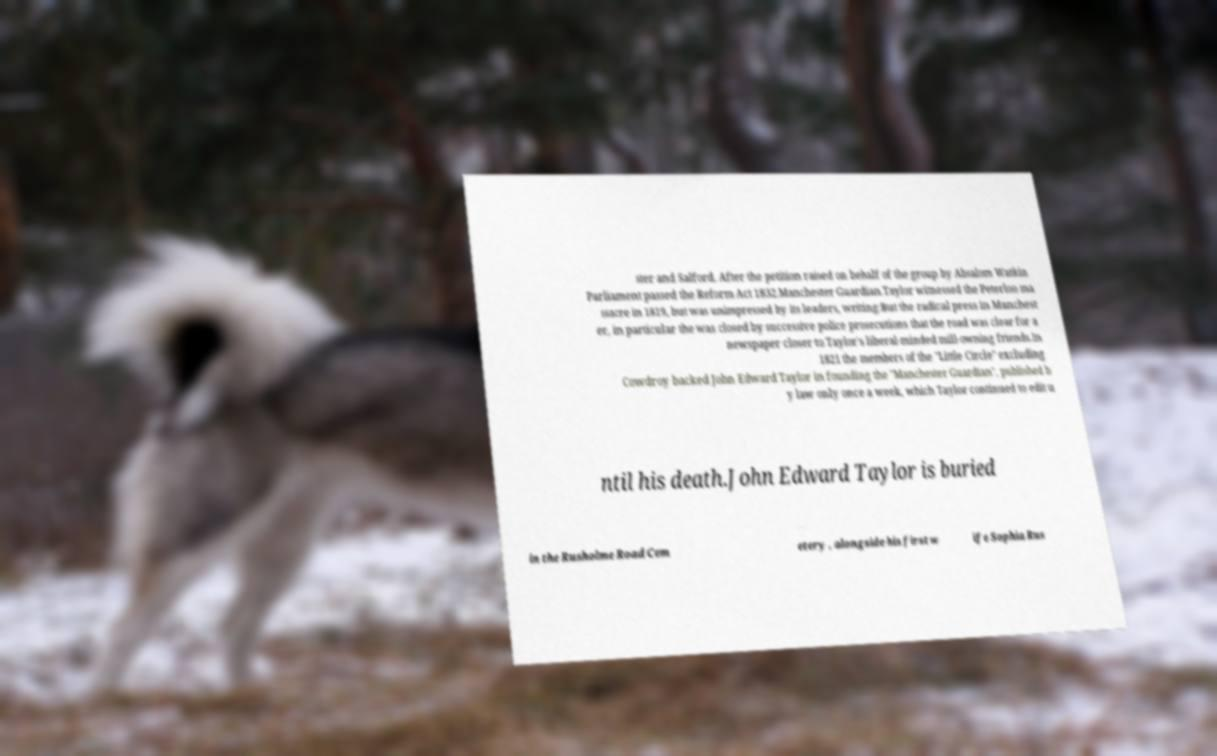What messages or text are displayed in this image? I need them in a readable, typed format. ster and Salford. After the petition raised on behalf of the group by Absalom Watkin Parliament passed the Reform Act 1832.Manchester Guardian.Taylor witnessed the Peterloo ma ssacre in 1819, but was unimpressed by its leaders, writing:But the radical press in Manchest er, in particular the was closed by successive police prosecutions that the road was clear for a newspaper closer to Taylor's liberal-minded mill-owning friends.In 1821 the members of the "Little Circle" excluding Cowdroy backed John Edward Taylor in founding the "Manchester Guardian", published b y law only once a week, which Taylor continued to edit u ntil his death.John Edward Taylor is buried in the Rusholme Road Cem etery , alongside his first w ife Sophia Rus 